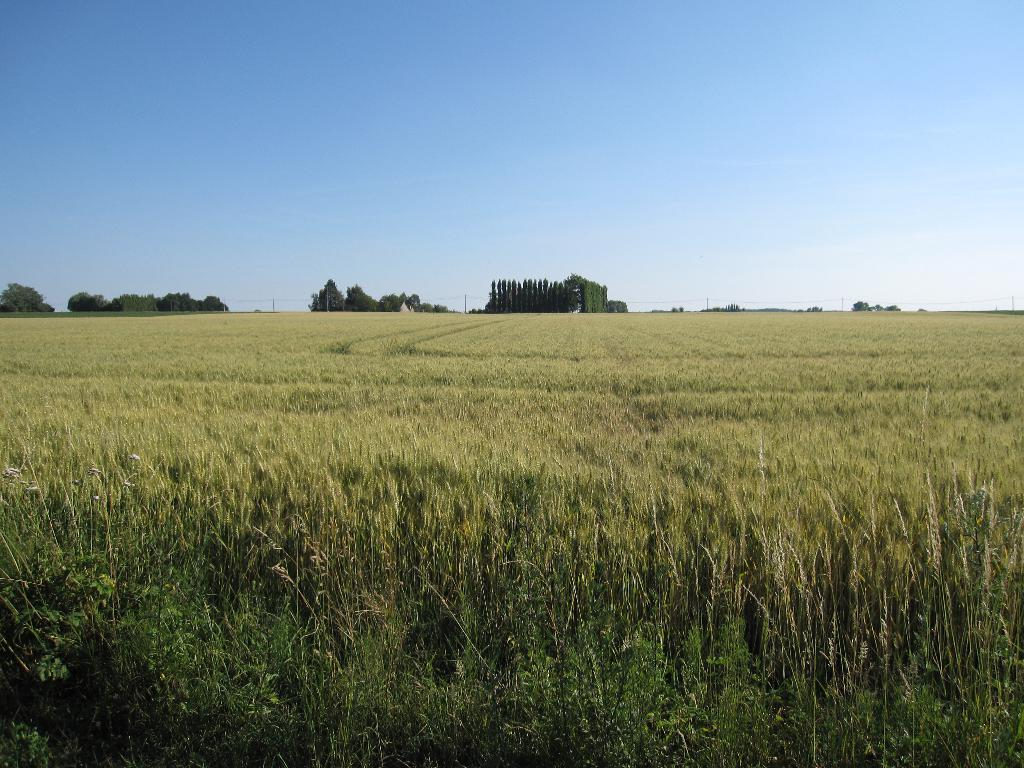What type of plants can be seen in the image? There is a crop with grass plants in the image. What else can be seen in the distance? Trees and poles are visible in the distance. What is visible in the sky in the image? The sky is visible in the image. What type of beam is holding up the balloon in the image? There is no beam or balloon present in the image. What type of vase can be seen on the grass in the image? There is no vase present in the image. 